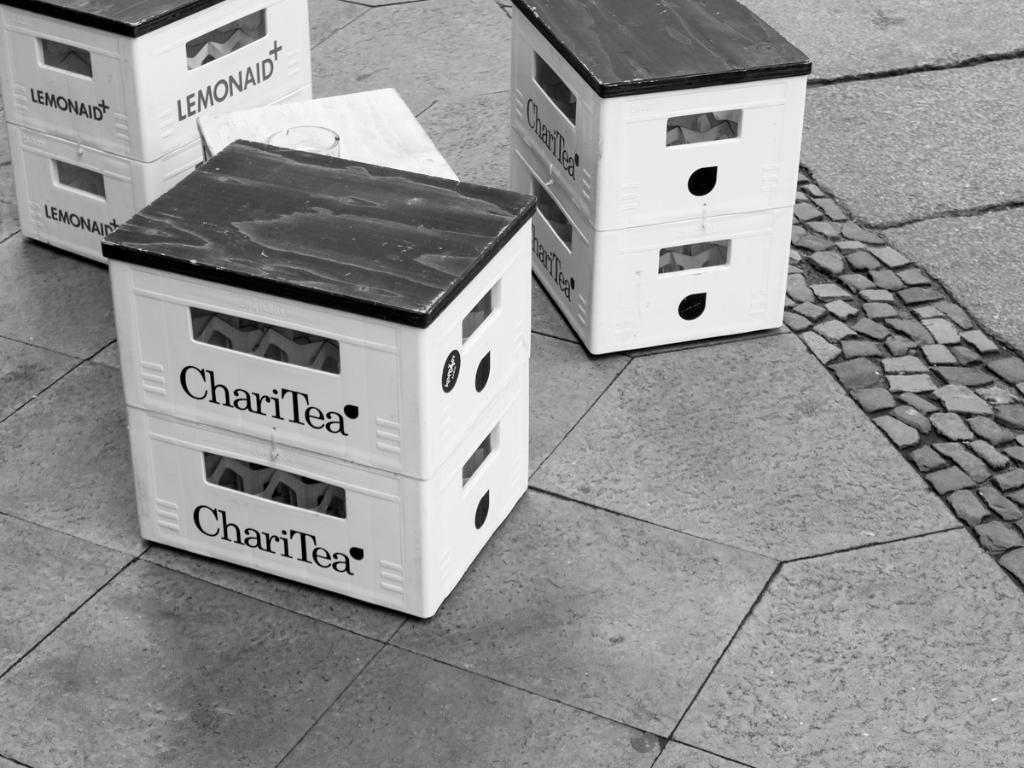<image>
Provide a brief description of the given image. Three sets of containers are sitting on the ground, two of which are labeled as ChariTea. 